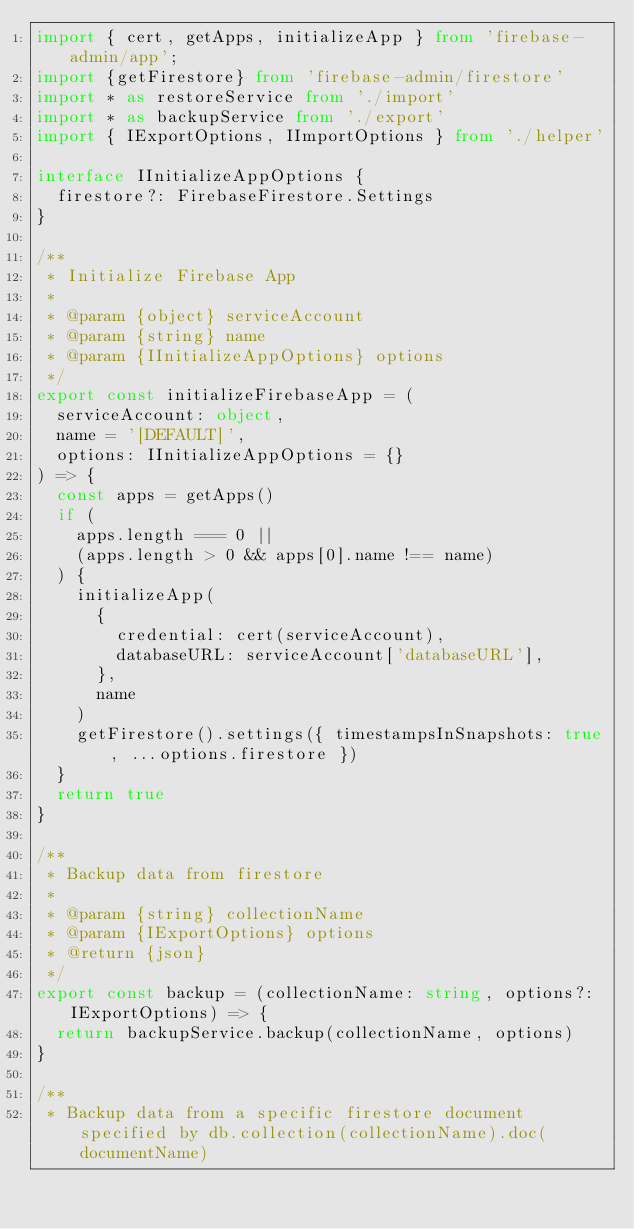<code> <loc_0><loc_0><loc_500><loc_500><_TypeScript_>import { cert, getApps, initializeApp } from 'firebase-admin/app';
import {getFirestore} from 'firebase-admin/firestore'
import * as restoreService from './import'
import * as backupService from './export'
import { IExportOptions, IImportOptions } from './helper'

interface IInitializeAppOptions {
  firestore?: FirebaseFirestore.Settings
}

/**
 * Initialize Firebase App
 *
 * @param {object} serviceAccount
 * @param {string} name
 * @param {IInitializeAppOptions} options
 */
export const initializeFirebaseApp = (
  serviceAccount: object,
  name = '[DEFAULT]',
  options: IInitializeAppOptions = {}
) => {
  const apps = getApps()
  if (
    apps.length === 0 ||
    (apps.length > 0 && apps[0].name !== name)
  ) {
    initializeApp(
      {
        credential: cert(serviceAccount),
        databaseURL: serviceAccount['databaseURL'],
      },
      name
    )
    getFirestore().settings({ timestampsInSnapshots: true, ...options.firestore })
  }
  return true
}

/**
 * Backup data from firestore
 *
 * @param {string} collectionName
 * @param {IExportOptions} options
 * @return {json}
 */
export const backup = (collectionName: string, options?: IExportOptions) => {
  return backupService.backup(collectionName, options)
}

/**
 * Backup data from a specific firestore document specified by db.collection(collectionName).doc(documentName)</code> 